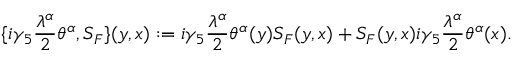Convert formula to latex. <formula><loc_0><loc_0><loc_500><loc_500>\{ i \gamma _ { 5 } \frac { \lambda ^ { \alpha } } { 2 } \theta ^ { \alpha } , S _ { F } \} ( y , x ) \colon = i \gamma _ { 5 } \frac { \lambda ^ { \alpha } } { 2 } \theta ^ { \alpha } ( y ) S _ { F } ( y , x ) + S _ { F } ( y , x ) i \gamma _ { 5 } \frac { \lambda ^ { \alpha } } { 2 } \theta ^ { \alpha } ( x ) .</formula> 